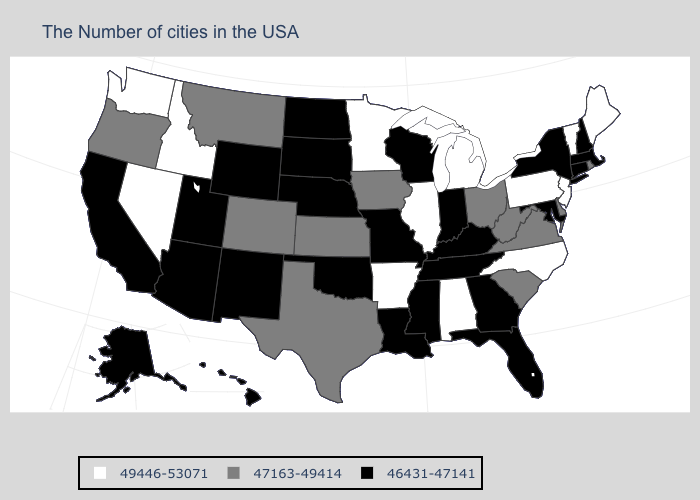Which states hav the highest value in the Northeast?
Answer briefly. Maine, Vermont, New Jersey, Pennsylvania. Does the first symbol in the legend represent the smallest category?
Be succinct. No. How many symbols are there in the legend?
Concise answer only. 3. Name the states that have a value in the range 49446-53071?
Write a very short answer. Maine, Vermont, New Jersey, Pennsylvania, North Carolina, Michigan, Alabama, Illinois, Arkansas, Minnesota, Idaho, Nevada, Washington. Name the states that have a value in the range 47163-49414?
Be succinct. Rhode Island, Delaware, Virginia, South Carolina, West Virginia, Ohio, Iowa, Kansas, Texas, Colorado, Montana, Oregon. What is the value of New Hampshire?
Quick response, please. 46431-47141. What is the value of Kentucky?
Concise answer only. 46431-47141. Does Minnesota have a higher value than Maryland?
Answer briefly. Yes. Name the states that have a value in the range 49446-53071?
Quick response, please. Maine, Vermont, New Jersey, Pennsylvania, North Carolina, Michigan, Alabama, Illinois, Arkansas, Minnesota, Idaho, Nevada, Washington. What is the lowest value in states that border Florida?
Give a very brief answer. 46431-47141. Which states have the lowest value in the USA?
Concise answer only. Massachusetts, New Hampshire, Connecticut, New York, Maryland, Florida, Georgia, Kentucky, Indiana, Tennessee, Wisconsin, Mississippi, Louisiana, Missouri, Nebraska, Oklahoma, South Dakota, North Dakota, Wyoming, New Mexico, Utah, Arizona, California, Alaska, Hawaii. Does Michigan have the lowest value in the USA?
Concise answer only. No. Name the states that have a value in the range 49446-53071?
Answer briefly. Maine, Vermont, New Jersey, Pennsylvania, North Carolina, Michigan, Alabama, Illinois, Arkansas, Minnesota, Idaho, Nevada, Washington. Name the states that have a value in the range 46431-47141?
Be succinct. Massachusetts, New Hampshire, Connecticut, New York, Maryland, Florida, Georgia, Kentucky, Indiana, Tennessee, Wisconsin, Mississippi, Louisiana, Missouri, Nebraska, Oklahoma, South Dakota, North Dakota, Wyoming, New Mexico, Utah, Arizona, California, Alaska, Hawaii. What is the highest value in the Northeast ?
Short answer required. 49446-53071. 